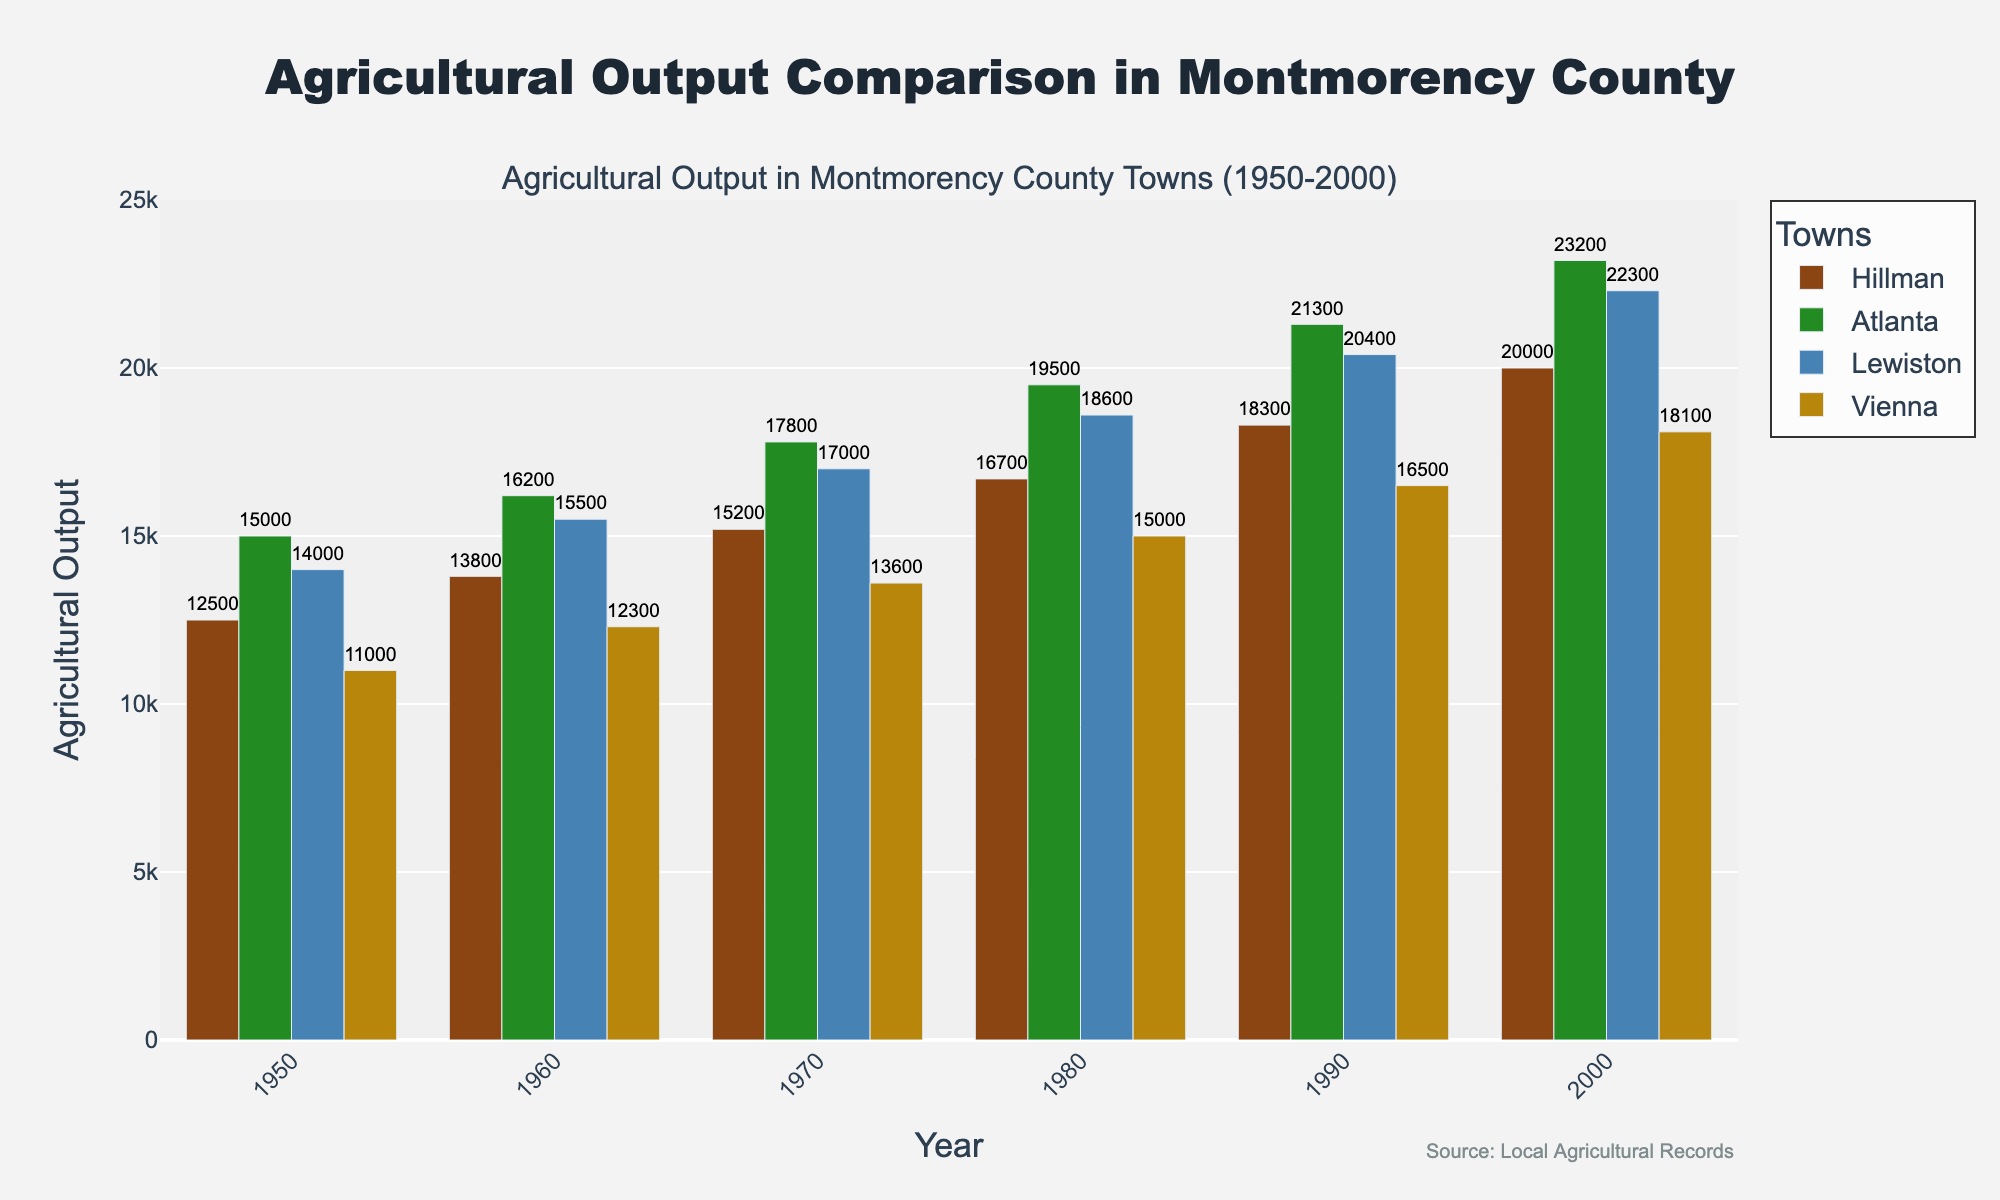Which town had the highest agricultural output in 1980? In 1980, the heights of the bars represent agricultural output for each town. The Atlanta bar is the highest.
Answer: Atlanta How much did Hillman's agricultural output increase from 1950 to 2000? To find the increase in Hillman, subtract the 1950 value from the 2000 value. So, 20000 - 12500 = 7500.
Answer: 7500 Which town showed the smallest increase in agricultural output from 1950 to 2000? Calculate the increase for each town: Hillman (7500), Atlanta (8200), Lewiston (8300), Vienna (7100). Vienna has the smallest increase.
Answer: Vienna What was the difference in agricultural output between Atlanta and Lewiston in 1990? In 1990, look at the bar heights for Atlanta (21300) and Lewiston (20400), then find the difference: 21300 - 20400 = 900.
Answer: 900 In which year was the agricultural output of Hillman closest to the agricultural output of Vienna? Compare year-by-year agricultural outputs of Hillman and Vienna: 
1950 (12500 vs 11000), 1960 (13800 vs 12300), 1970 (15200 vs 13600), 1980 (16700 vs 15000), 1990 (18300 vs 16500), 2000 (20000 vs 18100). All differences are equal at 1500.
Answer: All years, with a difference of 1500 Which town has consistently had the highest agricultural output over the years? Observing the height of the bars across all years, the town with the highest bar is consistently Atlanta.
Answer: Atlanta What is the average agricultural output of Lewiston from 1950 to 2000? Calculate the average by summing all values for Lewiston (14000, 15500, 17000, 18600, 20400, 22300) and dividing by the number of values: (14000 + 15500 + 17000 + 18600 + 20400 + 22300) / 6 = 17900.
Answer: 17900 In which year did Atlanta's agricultural output surpass 20000? By examining the heights visually, it surpasses 20000 in the year 2000.
Answer: 2000 How many years did Hillman have an agricultural output greater than 15000? Checking the bar heights for Hillman: Years 1970-2000 all have outputs greater than 15000, which totals 4 years.
Answer: 4 